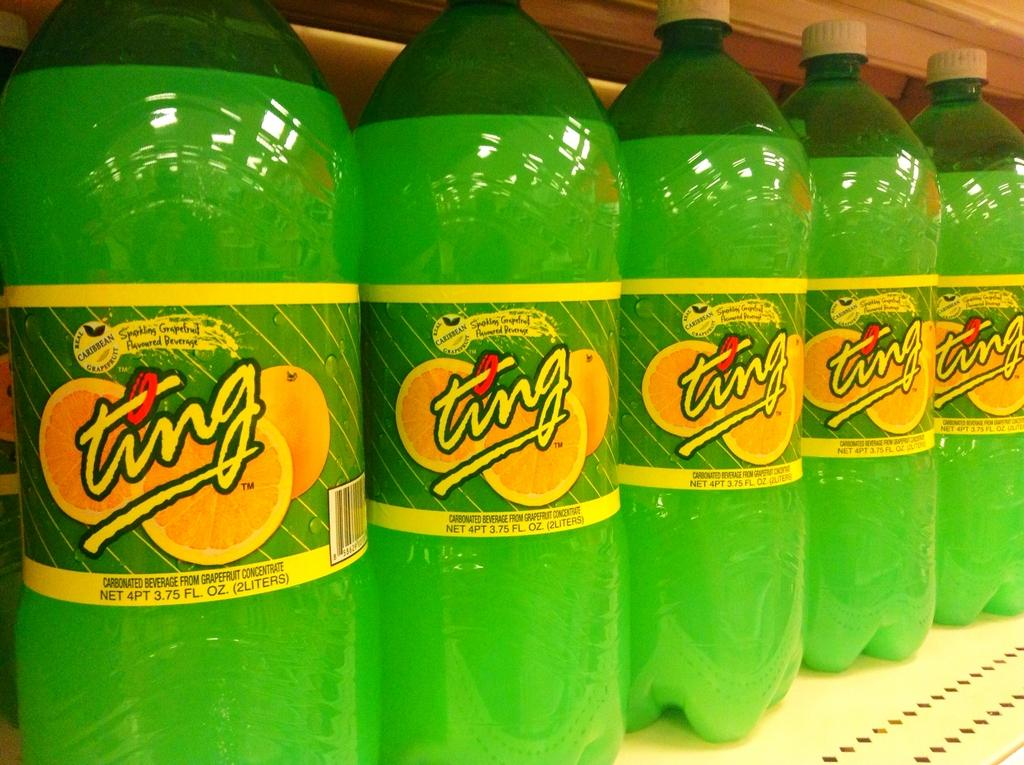<image>
Share a concise interpretation of the image provided. the word ting is on the green bottle 